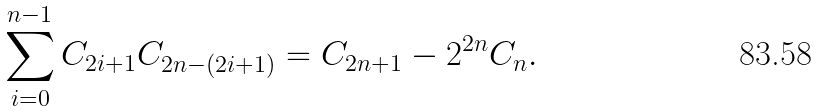<formula> <loc_0><loc_0><loc_500><loc_500>\sum _ { i = 0 } ^ { n - 1 } C _ { 2 i + 1 } C _ { 2 n - ( 2 i + 1 ) } = C _ { 2 n + 1 } - 2 ^ { 2 n } C _ { n } .</formula> 